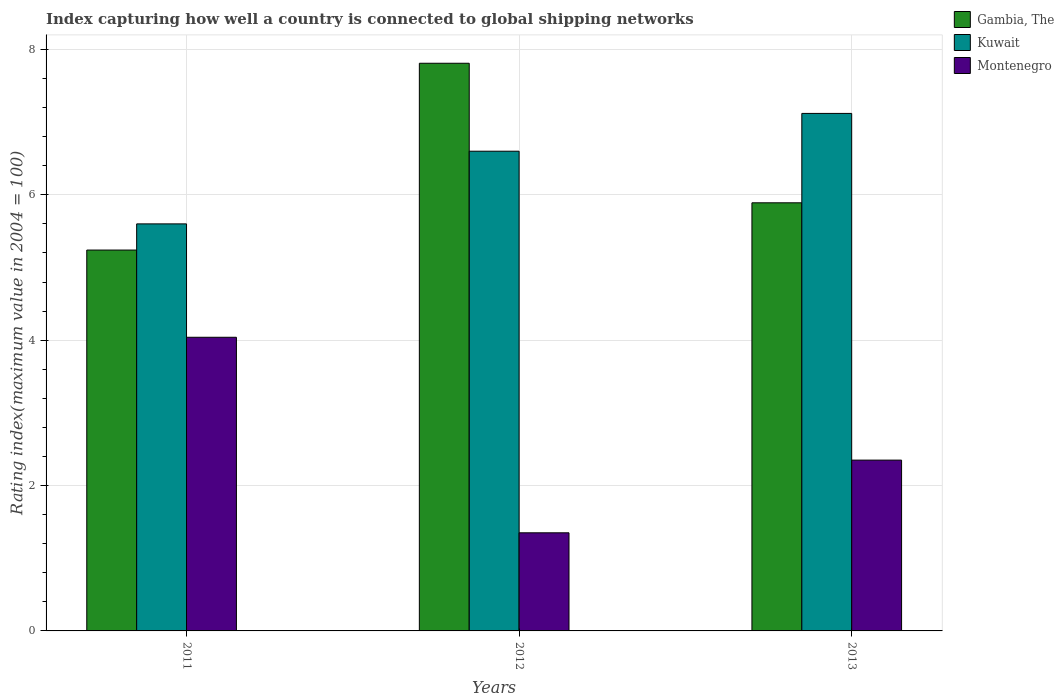How many different coloured bars are there?
Keep it short and to the point. 3. Are the number of bars per tick equal to the number of legend labels?
Offer a terse response. Yes. How many bars are there on the 1st tick from the right?
Give a very brief answer. 3. In how many cases, is the number of bars for a given year not equal to the number of legend labels?
Offer a terse response. 0. What is the rating index in Kuwait in 2013?
Offer a terse response. 7.12. Across all years, what is the maximum rating index in Gambia, The?
Keep it short and to the point. 7.81. Across all years, what is the minimum rating index in Gambia, The?
Ensure brevity in your answer.  5.24. In which year was the rating index in Gambia, The minimum?
Your response must be concise. 2011. What is the total rating index in Montenegro in the graph?
Provide a succinct answer. 7.74. What is the difference between the rating index in Montenegro in 2011 and that in 2012?
Make the answer very short. 2.69. What is the difference between the rating index in Gambia, The in 2012 and the rating index in Kuwait in 2013?
Keep it short and to the point. 0.69. What is the average rating index in Montenegro per year?
Your answer should be compact. 2.58. In the year 2013, what is the difference between the rating index in Montenegro and rating index in Kuwait?
Make the answer very short. -4.77. What is the ratio of the rating index in Kuwait in 2011 to that in 2012?
Provide a short and direct response. 0.85. Is the rating index in Montenegro in 2012 less than that in 2013?
Provide a short and direct response. Yes. What is the difference between the highest and the second highest rating index in Montenegro?
Ensure brevity in your answer.  1.69. What is the difference between the highest and the lowest rating index in Kuwait?
Provide a short and direct response. 1.52. In how many years, is the rating index in Montenegro greater than the average rating index in Montenegro taken over all years?
Keep it short and to the point. 1. Is the sum of the rating index in Gambia, The in 2012 and 2013 greater than the maximum rating index in Montenegro across all years?
Provide a short and direct response. Yes. What does the 3rd bar from the left in 2011 represents?
Offer a terse response. Montenegro. What does the 1st bar from the right in 2012 represents?
Keep it short and to the point. Montenegro. Is it the case that in every year, the sum of the rating index in Montenegro and rating index in Gambia, The is greater than the rating index in Kuwait?
Make the answer very short. Yes. How many bars are there?
Give a very brief answer. 9. Are all the bars in the graph horizontal?
Keep it short and to the point. No. How many years are there in the graph?
Give a very brief answer. 3. What is the difference between two consecutive major ticks on the Y-axis?
Keep it short and to the point. 2. Are the values on the major ticks of Y-axis written in scientific E-notation?
Offer a terse response. No. Does the graph contain grids?
Offer a terse response. Yes. Where does the legend appear in the graph?
Provide a short and direct response. Top right. How many legend labels are there?
Your answer should be very brief. 3. What is the title of the graph?
Offer a very short reply. Index capturing how well a country is connected to global shipping networks. What is the label or title of the X-axis?
Your answer should be compact. Years. What is the label or title of the Y-axis?
Provide a succinct answer. Rating index(maximum value in 2004 = 100). What is the Rating index(maximum value in 2004 = 100) in Gambia, The in 2011?
Provide a succinct answer. 5.24. What is the Rating index(maximum value in 2004 = 100) in Montenegro in 2011?
Offer a terse response. 4.04. What is the Rating index(maximum value in 2004 = 100) of Gambia, The in 2012?
Ensure brevity in your answer.  7.81. What is the Rating index(maximum value in 2004 = 100) of Montenegro in 2012?
Offer a terse response. 1.35. What is the Rating index(maximum value in 2004 = 100) of Gambia, The in 2013?
Your response must be concise. 5.89. What is the Rating index(maximum value in 2004 = 100) in Kuwait in 2013?
Give a very brief answer. 7.12. What is the Rating index(maximum value in 2004 = 100) of Montenegro in 2013?
Offer a very short reply. 2.35. Across all years, what is the maximum Rating index(maximum value in 2004 = 100) of Gambia, The?
Provide a succinct answer. 7.81. Across all years, what is the maximum Rating index(maximum value in 2004 = 100) of Kuwait?
Your response must be concise. 7.12. Across all years, what is the maximum Rating index(maximum value in 2004 = 100) of Montenegro?
Your answer should be compact. 4.04. Across all years, what is the minimum Rating index(maximum value in 2004 = 100) in Gambia, The?
Give a very brief answer. 5.24. Across all years, what is the minimum Rating index(maximum value in 2004 = 100) in Kuwait?
Give a very brief answer. 5.6. Across all years, what is the minimum Rating index(maximum value in 2004 = 100) in Montenegro?
Give a very brief answer. 1.35. What is the total Rating index(maximum value in 2004 = 100) of Gambia, The in the graph?
Provide a short and direct response. 18.94. What is the total Rating index(maximum value in 2004 = 100) in Kuwait in the graph?
Ensure brevity in your answer.  19.32. What is the total Rating index(maximum value in 2004 = 100) of Montenegro in the graph?
Your answer should be very brief. 7.74. What is the difference between the Rating index(maximum value in 2004 = 100) of Gambia, The in 2011 and that in 2012?
Offer a very short reply. -2.57. What is the difference between the Rating index(maximum value in 2004 = 100) in Montenegro in 2011 and that in 2012?
Provide a succinct answer. 2.69. What is the difference between the Rating index(maximum value in 2004 = 100) in Gambia, The in 2011 and that in 2013?
Make the answer very short. -0.65. What is the difference between the Rating index(maximum value in 2004 = 100) of Kuwait in 2011 and that in 2013?
Offer a terse response. -1.52. What is the difference between the Rating index(maximum value in 2004 = 100) in Montenegro in 2011 and that in 2013?
Provide a short and direct response. 1.69. What is the difference between the Rating index(maximum value in 2004 = 100) in Gambia, The in 2012 and that in 2013?
Ensure brevity in your answer.  1.92. What is the difference between the Rating index(maximum value in 2004 = 100) of Kuwait in 2012 and that in 2013?
Keep it short and to the point. -0.52. What is the difference between the Rating index(maximum value in 2004 = 100) of Montenegro in 2012 and that in 2013?
Offer a terse response. -1. What is the difference between the Rating index(maximum value in 2004 = 100) of Gambia, The in 2011 and the Rating index(maximum value in 2004 = 100) of Kuwait in 2012?
Give a very brief answer. -1.36. What is the difference between the Rating index(maximum value in 2004 = 100) of Gambia, The in 2011 and the Rating index(maximum value in 2004 = 100) of Montenegro in 2012?
Give a very brief answer. 3.89. What is the difference between the Rating index(maximum value in 2004 = 100) of Kuwait in 2011 and the Rating index(maximum value in 2004 = 100) of Montenegro in 2012?
Make the answer very short. 4.25. What is the difference between the Rating index(maximum value in 2004 = 100) of Gambia, The in 2011 and the Rating index(maximum value in 2004 = 100) of Kuwait in 2013?
Ensure brevity in your answer.  -1.88. What is the difference between the Rating index(maximum value in 2004 = 100) in Gambia, The in 2011 and the Rating index(maximum value in 2004 = 100) in Montenegro in 2013?
Provide a succinct answer. 2.89. What is the difference between the Rating index(maximum value in 2004 = 100) of Gambia, The in 2012 and the Rating index(maximum value in 2004 = 100) of Kuwait in 2013?
Offer a very short reply. 0.69. What is the difference between the Rating index(maximum value in 2004 = 100) of Gambia, The in 2012 and the Rating index(maximum value in 2004 = 100) of Montenegro in 2013?
Your response must be concise. 5.46. What is the difference between the Rating index(maximum value in 2004 = 100) in Kuwait in 2012 and the Rating index(maximum value in 2004 = 100) in Montenegro in 2013?
Ensure brevity in your answer.  4.25. What is the average Rating index(maximum value in 2004 = 100) of Gambia, The per year?
Your answer should be very brief. 6.31. What is the average Rating index(maximum value in 2004 = 100) of Kuwait per year?
Give a very brief answer. 6.44. What is the average Rating index(maximum value in 2004 = 100) in Montenegro per year?
Your response must be concise. 2.58. In the year 2011, what is the difference between the Rating index(maximum value in 2004 = 100) of Gambia, The and Rating index(maximum value in 2004 = 100) of Kuwait?
Provide a short and direct response. -0.36. In the year 2011, what is the difference between the Rating index(maximum value in 2004 = 100) in Kuwait and Rating index(maximum value in 2004 = 100) in Montenegro?
Your response must be concise. 1.56. In the year 2012, what is the difference between the Rating index(maximum value in 2004 = 100) of Gambia, The and Rating index(maximum value in 2004 = 100) of Kuwait?
Offer a terse response. 1.21. In the year 2012, what is the difference between the Rating index(maximum value in 2004 = 100) in Gambia, The and Rating index(maximum value in 2004 = 100) in Montenegro?
Make the answer very short. 6.46. In the year 2012, what is the difference between the Rating index(maximum value in 2004 = 100) in Kuwait and Rating index(maximum value in 2004 = 100) in Montenegro?
Keep it short and to the point. 5.25. In the year 2013, what is the difference between the Rating index(maximum value in 2004 = 100) of Gambia, The and Rating index(maximum value in 2004 = 100) of Kuwait?
Give a very brief answer. -1.23. In the year 2013, what is the difference between the Rating index(maximum value in 2004 = 100) in Gambia, The and Rating index(maximum value in 2004 = 100) in Montenegro?
Your response must be concise. 3.54. In the year 2013, what is the difference between the Rating index(maximum value in 2004 = 100) in Kuwait and Rating index(maximum value in 2004 = 100) in Montenegro?
Ensure brevity in your answer.  4.77. What is the ratio of the Rating index(maximum value in 2004 = 100) in Gambia, The in 2011 to that in 2012?
Your answer should be compact. 0.67. What is the ratio of the Rating index(maximum value in 2004 = 100) of Kuwait in 2011 to that in 2012?
Give a very brief answer. 0.85. What is the ratio of the Rating index(maximum value in 2004 = 100) in Montenegro in 2011 to that in 2012?
Your answer should be compact. 2.99. What is the ratio of the Rating index(maximum value in 2004 = 100) of Gambia, The in 2011 to that in 2013?
Give a very brief answer. 0.89. What is the ratio of the Rating index(maximum value in 2004 = 100) in Kuwait in 2011 to that in 2013?
Offer a very short reply. 0.79. What is the ratio of the Rating index(maximum value in 2004 = 100) in Montenegro in 2011 to that in 2013?
Your response must be concise. 1.72. What is the ratio of the Rating index(maximum value in 2004 = 100) in Gambia, The in 2012 to that in 2013?
Give a very brief answer. 1.33. What is the ratio of the Rating index(maximum value in 2004 = 100) in Kuwait in 2012 to that in 2013?
Give a very brief answer. 0.93. What is the ratio of the Rating index(maximum value in 2004 = 100) of Montenegro in 2012 to that in 2013?
Provide a succinct answer. 0.57. What is the difference between the highest and the second highest Rating index(maximum value in 2004 = 100) in Gambia, The?
Provide a short and direct response. 1.92. What is the difference between the highest and the second highest Rating index(maximum value in 2004 = 100) of Kuwait?
Provide a short and direct response. 0.52. What is the difference between the highest and the second highest Rating index(maximum value in 2004 = 100) of Montenegro?
Ensure brevity in your answer.  1.69. What is the difference between the highest and the lowest Rating index(maximum value in 2004 = 100) of Gambia, The?
Provide a succinct answer. 2.57. What is the difference between the highest and the lowest Rating index(maximum value in 2004 = 100) in Kuwait?
Your answer should be compact. 1.52. What is the difference between the highest and the lowest Rating index(maximum value in 2004 = 100) in Montenegro?
Ensure brevity in your answer.  2.69. 